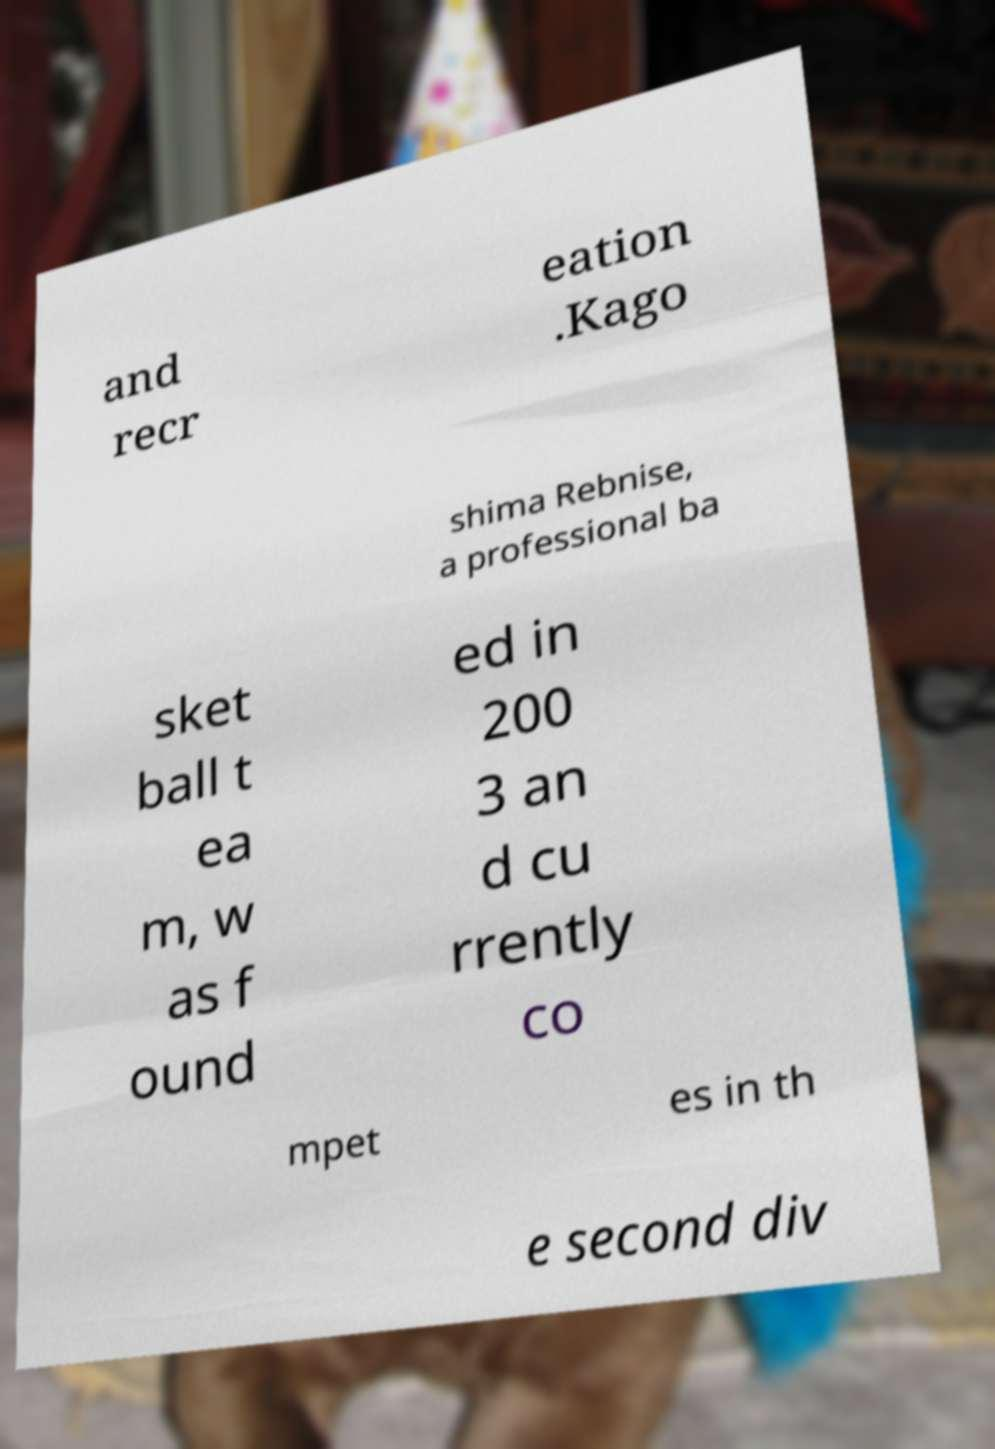Please read and relay the text visible in this image. What does it say? and recr eation .Kago shima Rebnise, a professional ba sket ball t ea m, w as f ound ed in 200 3 an d cu rrently co mpet es in th e second div 